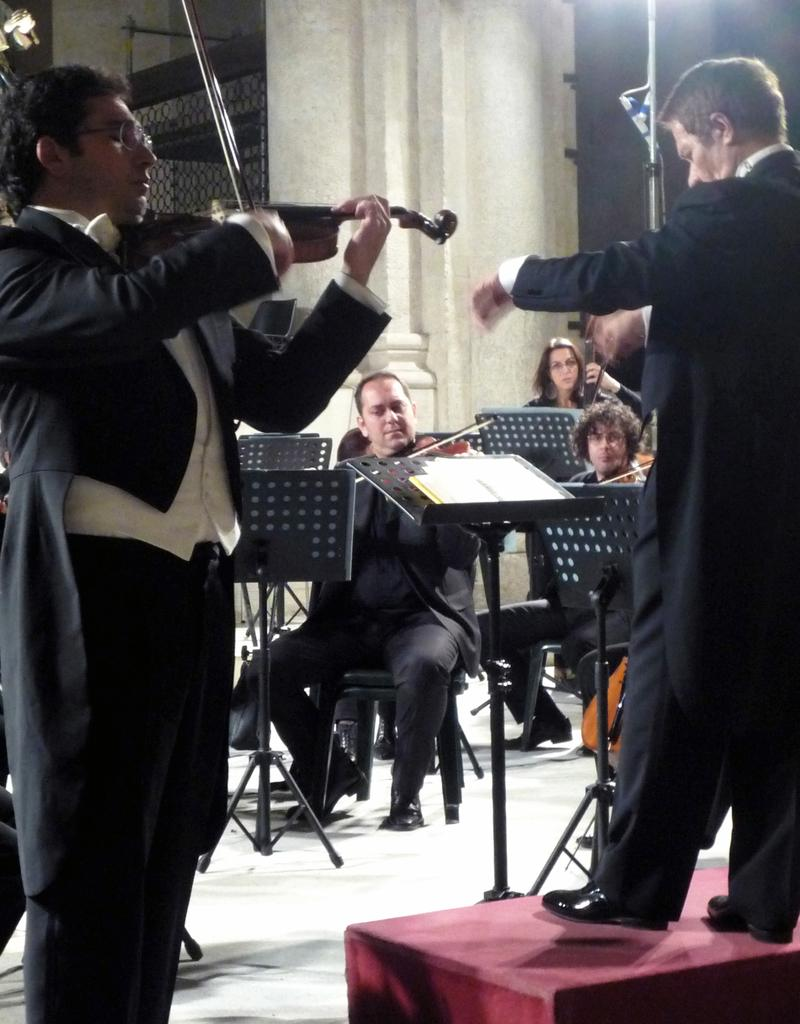How many people are sitting in the image? There are three persons sitting on chairs in the image. What are the sitting persons doing? The sitting persons are playing musical instruments. Are there any standing individuals in the image? Yes, there are two men standing in the image. What are the standing men doing? The standing men are playing a violin. How many cows are visible in the image? There are no cows present in the image. What type of trousers are the standing men wearing? The provided facts do not mention the type of trousers the standing men are wearing. Is there a light bulb visible in the image? There is no mention of a light bulb in the provided facts, so it cannot be determined if one is present in the image. 